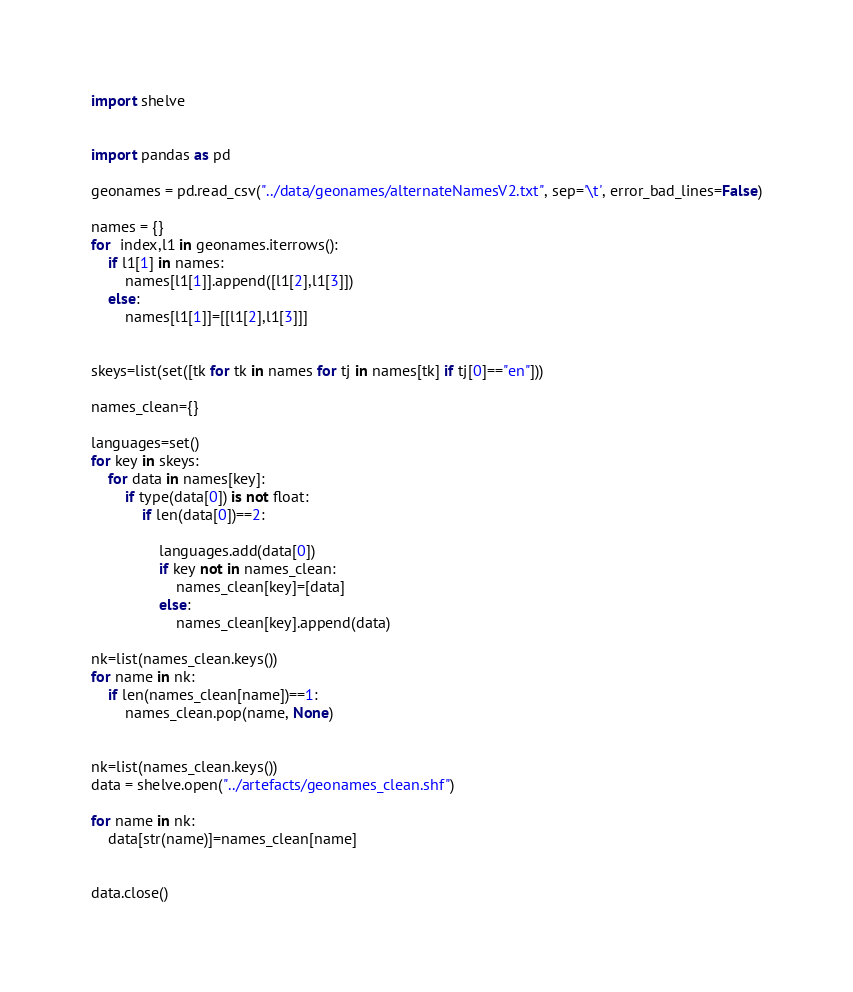<code> <loc_0><loc_0><loc_500><loc_500><_Python_>import shelve


import pandas as pd

geonames = pd.read_csv("../data/geonames/alternateNamesV2.txt", sep='\t', error_bad_lines=False)

names = {}
for  index,l1 in geonames.iterrows():
    if l1[1] in names:
        names[l1[1]].append([l1[2],l1[3]])
    else:
        names[l1[1]]=[[l1[2],l1[3]]]


skeys=list(set([tk for tk in names for tj in names[tk] if tj[0]=="en"]))

names_clean={}

languages=set()
for key in skeys:
    for data in names[key]:
        if type(data[0]) is not float:
            if len(data[0])==2:

                languages.add(data[0])
                if key not in names_clean:
                    names_clean[key]=[data]
                else:
                    names_clean[key].append(data)

nk=list(names_clean.keys())
for name in nk:
    if len(names_clean[name])==1:
        names_clean.pop(name, None)


nk=list(names_clean.keys())
data = shelve.open("../artefacts/geonames_clean.shf")

for name in nk:
    data[str(name)]=names_clean[name]


data.close()
</code> 